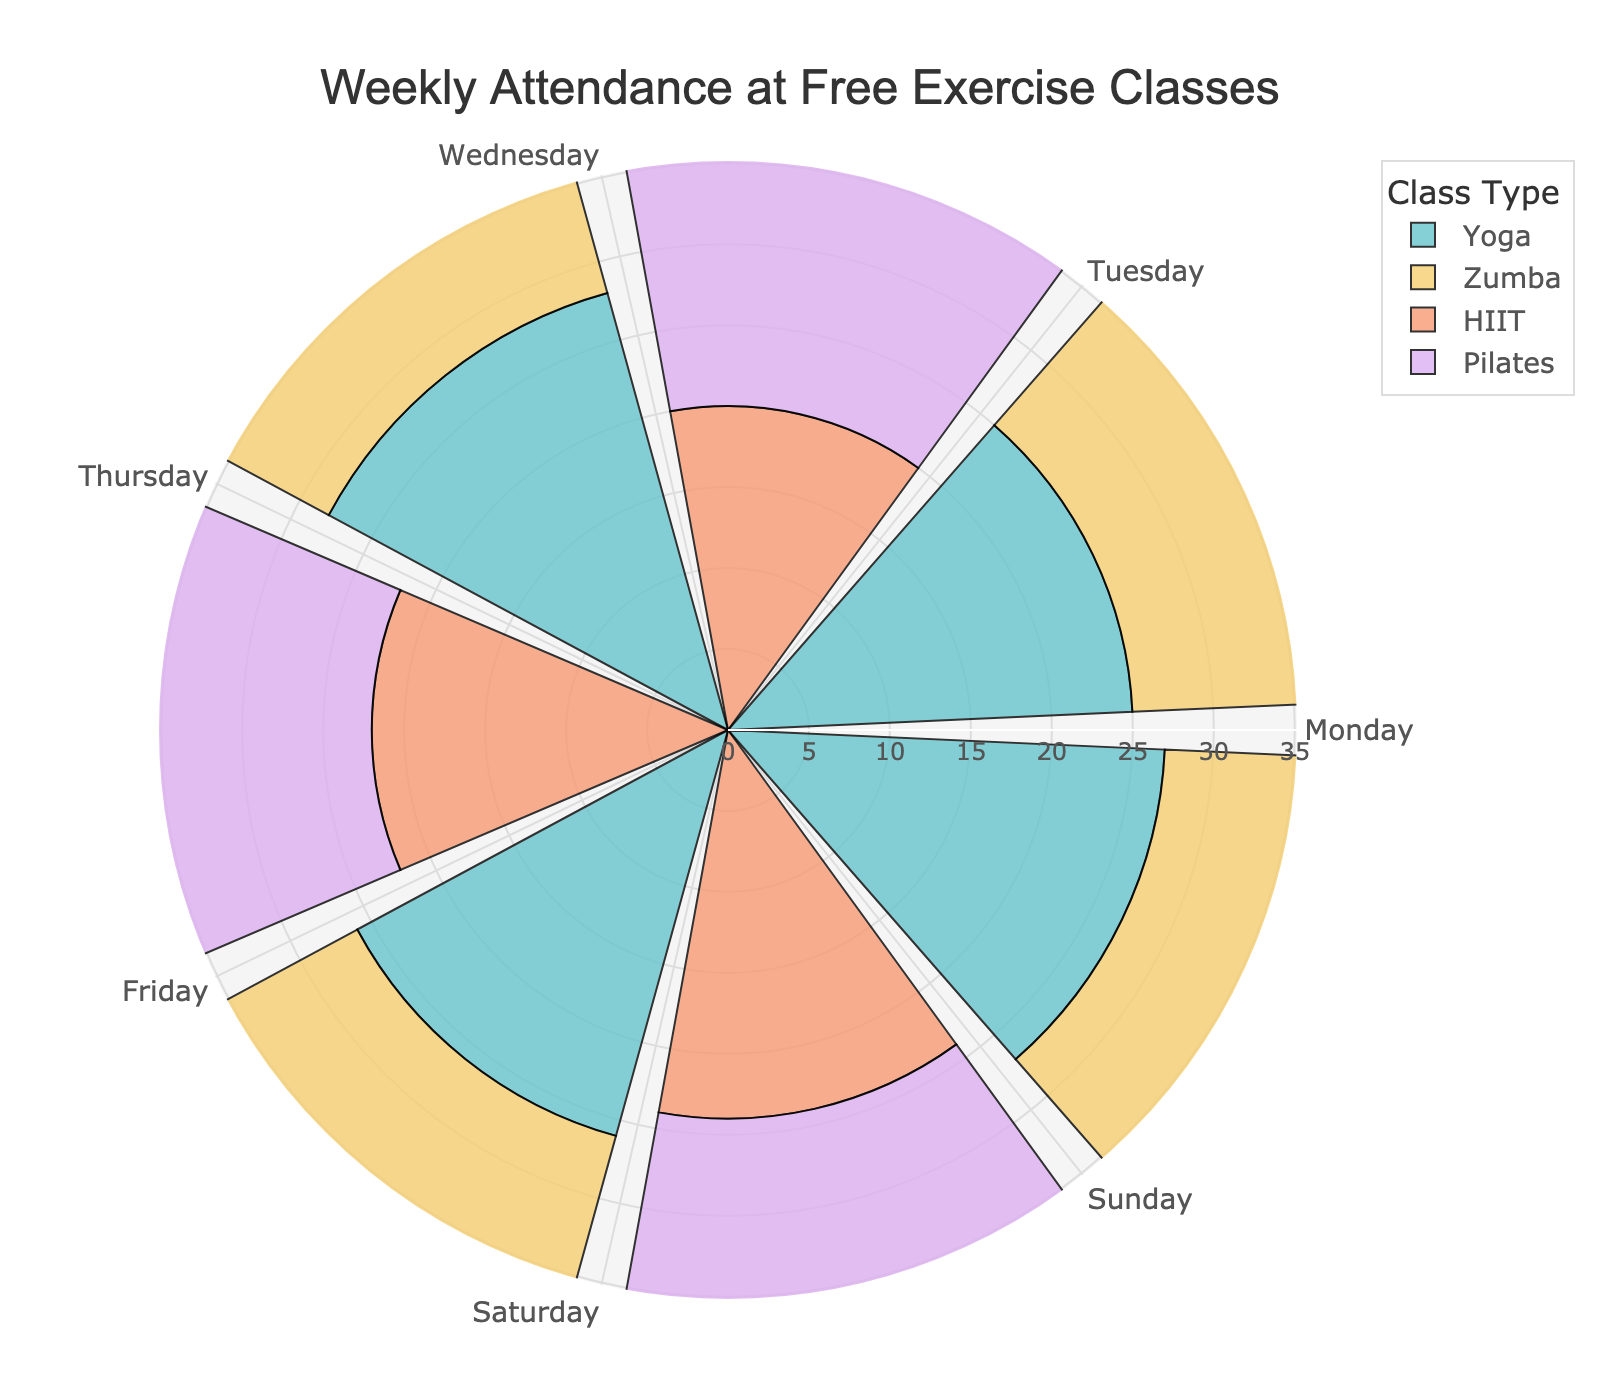what is the title of the figure? The title of the figure is placed prominently at the top and can be easily read from the visualization.
Answer: Weekly Attendance at Free Exercise Classes Which day has the highest attendance for Yoga classes? By looking at the segments of the rose chart and comparing the radius of the bars labeled with Yoga, the longest bar indicates the highest attendance.
Answer: Wednesday What is the total attendance for Zumba classes throughout the week? Sum the attendance numbers for Zumba classes on Monday, Wednesday, Friday, and Sunday: 30 + 32 + 29 + 31.
Answer: 122 Compare the attendance of HIIT and Pilates classes on Thursday. Which one is higher? Look at the radius of the bars corresponding to HIIT and Pilates on Thursday. HIIT has a radius of 22 and Pilates has a radius of 19.
Answer: HIIT On which day does Pilates have the lowest attendance? By examining the radius of the Pilates bars on different days of the week, the shortest radius represents the lowest attendance.
Answer: Tuesday What is the average attendance for Yoga classes throughout the week? Sum the attendance numbers for Yoga on Monday, Wednesday, Friday, and Sunday: (25 + 28 + 26 + 27) = 106. Divide by 4 to get the average: 106 / 4.
Answer: 26.5 Which class type has the most consistent attendance throughout the week? Look at the variations in the radius lengths for each class type. The class with the least variation in radius lengths is the most consistent.
Answer: Pilates How much does Zumba attendance on Wednesday exceed the HIIT attendance on Tuesday? Subtract the attendance for HIIT on Tuesday (20) from the attendance for Zumba on Wednesday (32): 32 - 20.
Answer: 12 Does any class type have the same attendance on two different days? Which class and on which days? By comparing the radius lengths for each class type across the different days, you can see that Pilates has the same attendance on Thursday and Saturday: 19 and 19.
Answer: Pilates on Thursday and Saturday Which class type has the lowest total attendance throughout the week and what is that total? Sum the attendance for each class type: Yoga (25+28+26+27), Zumba (30+32+29+31), HIIT (20+22+24), and Pilates (18+19+21). The total for Pilates is the lowest: (18+19+21) and 58.
Answer: Pilates, 58 